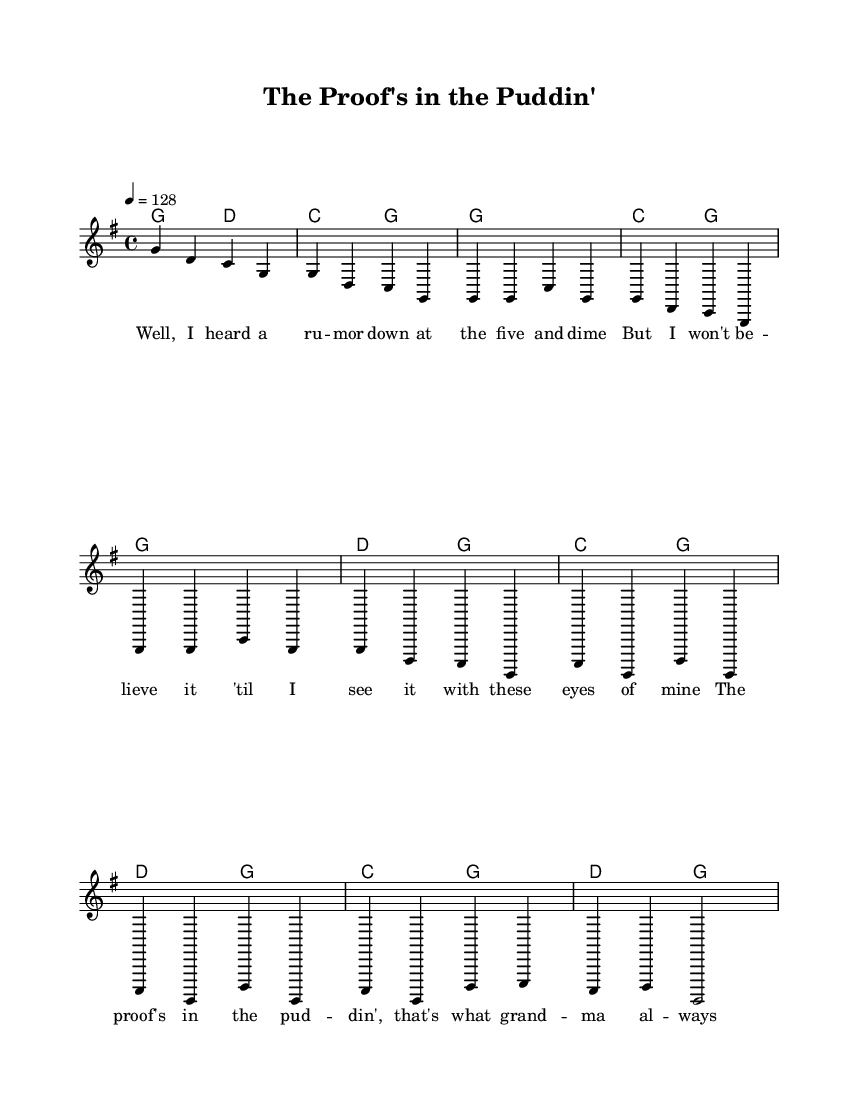What is the key signature of this music? The key signature is G major, which has one sharp (F#). This can be inferred from the key signature indication at the beginning of the score.
Answer: G major What is the time signature of this music? The time signature is 4/4, as indicated at the start of the piece. This means there are four beats in each measure and the quarter note gets one beat.
Answer: 4/4 What is the tempo marking for this piece? The tempo marking is 128 beats per minute, denoted by the number following the tempo indication. This dictates the speed of the music.
Answer: 128 How many measures are there in the verse? The verse consists of 8 measures, which is determined by counting the individual bars in the verse section indicated in the melodic line.
Answer: 8 What style of music is represented here? The style of music represented here is Country, indicated by the genre and instrumentation typically associated with folk and bluegrass influences.
Answer: Country What is the primary theme of the lyrics in this song? The primary theme is the importance of evidence-based decision-making, as evidenced by the lyrics that caution against jumping to conclusions and emphasize using facts.
Answer: Evidence-based decision-making Which chord is played at the start of the chorus? The chord played at the start of the chorus is C major, identified by looking at the chord notations aligned with the lyrics in the score.
Answer: C 